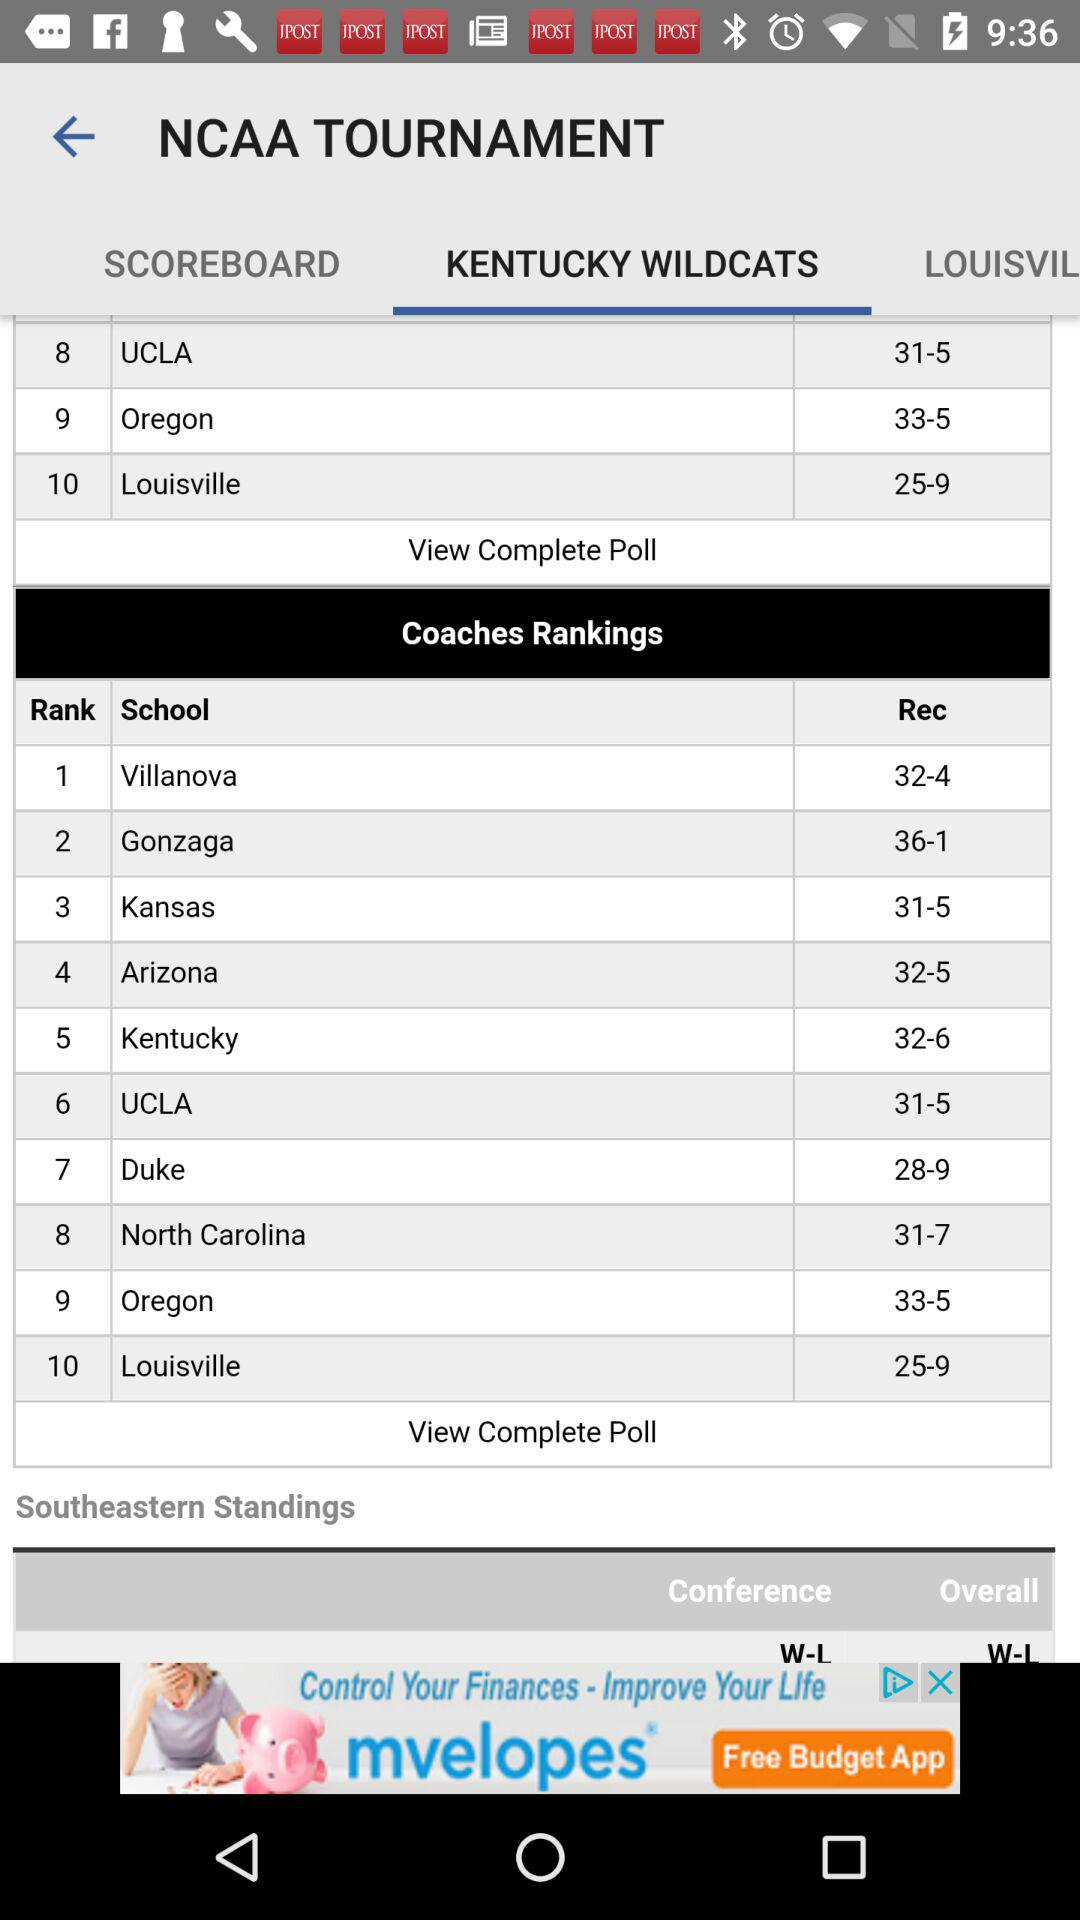What is the ranking of the coach at "UCLA"? The coach at "UCLA" is ranked sixth. 